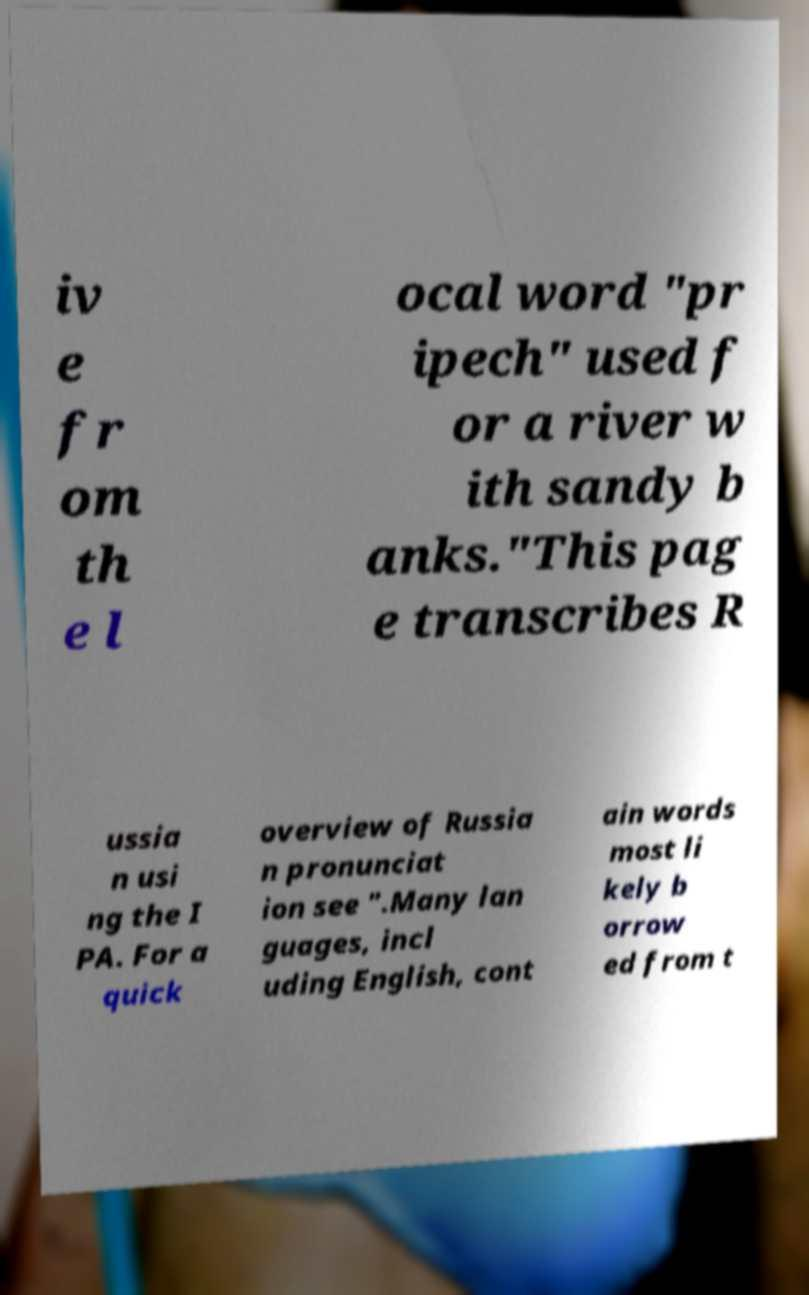Can you read and provide the text displayed in the image?This photo seems to have some interesting text. Can you extract and type it out for me? iv e fr om th e l ocal word "pr ipech" used f or a river w ith sandy b anks."This pag e transcribes R ussia n usi ng the I PA. For a quick overview of Russia n pronunciat ion see ".Many lan guages, incl uding English, cont ain words most li kely b orrow ed from t 